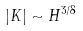<formula> <loc_0><loc_0><loc_500><loc_500>\left | K \right | \sim H ^ { 3 / 8 }</formula> 